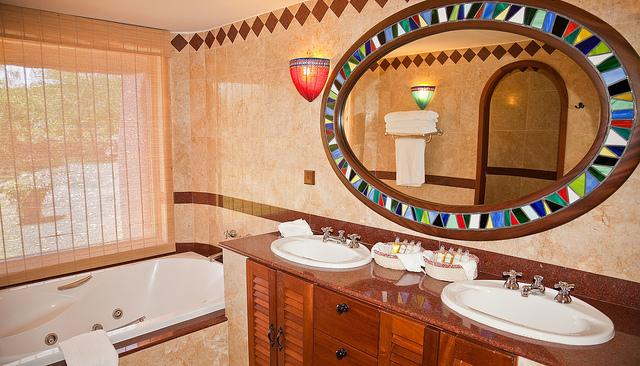Why does the tub have round silver objects on it?

Choices:
A) hot water
B) drainage
C) childs toys
D) whirlpool whirlpool 